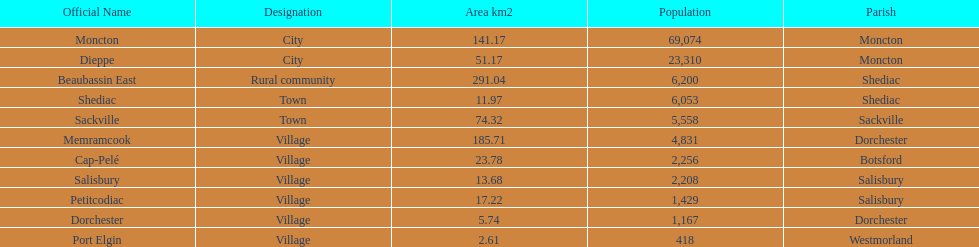In which city is the population the greatest? Moncton. 